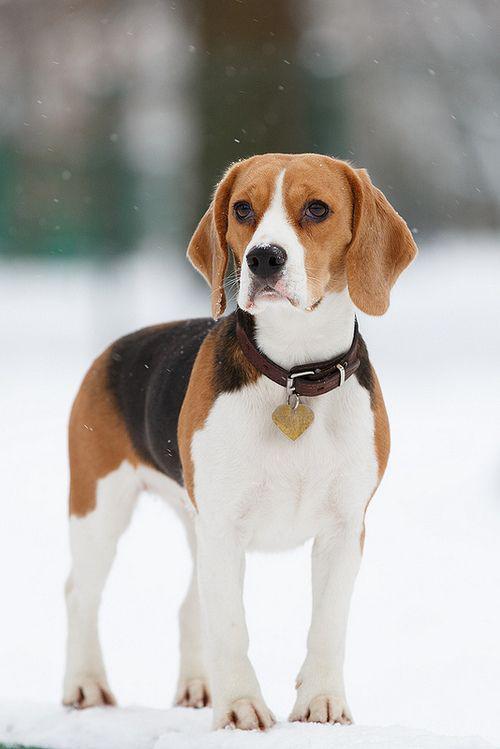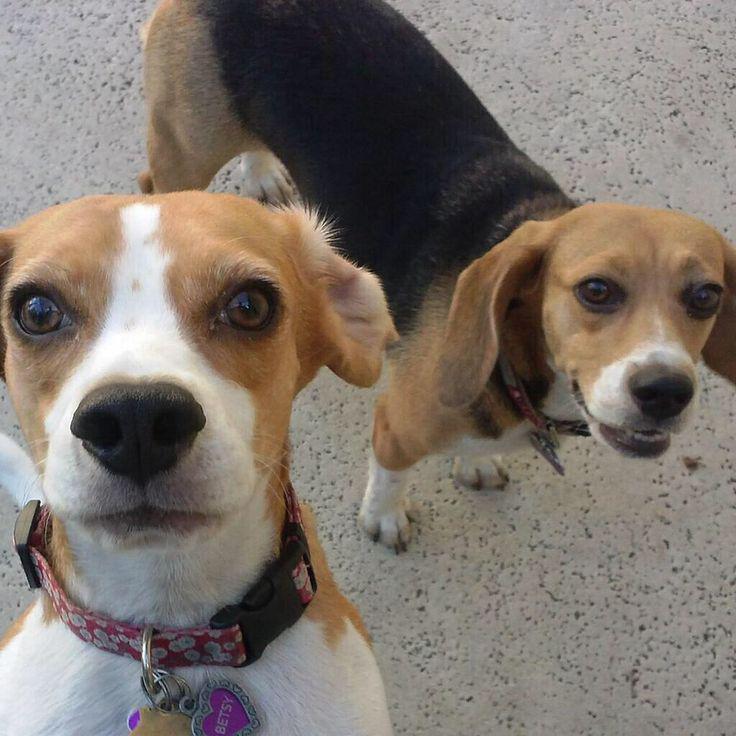The first image is the image on the left, the second image is the image on the right. For the images shown, is this caption "In one image there is a single puppy sitting on the ground." true? Answer yes or no. No. The first image is the image on the left, the second image is the image on the right. For the images displayed, is the sentence "There is one puppy sitting by itself in one of the images." factually correct? Answer yes or no. No. 